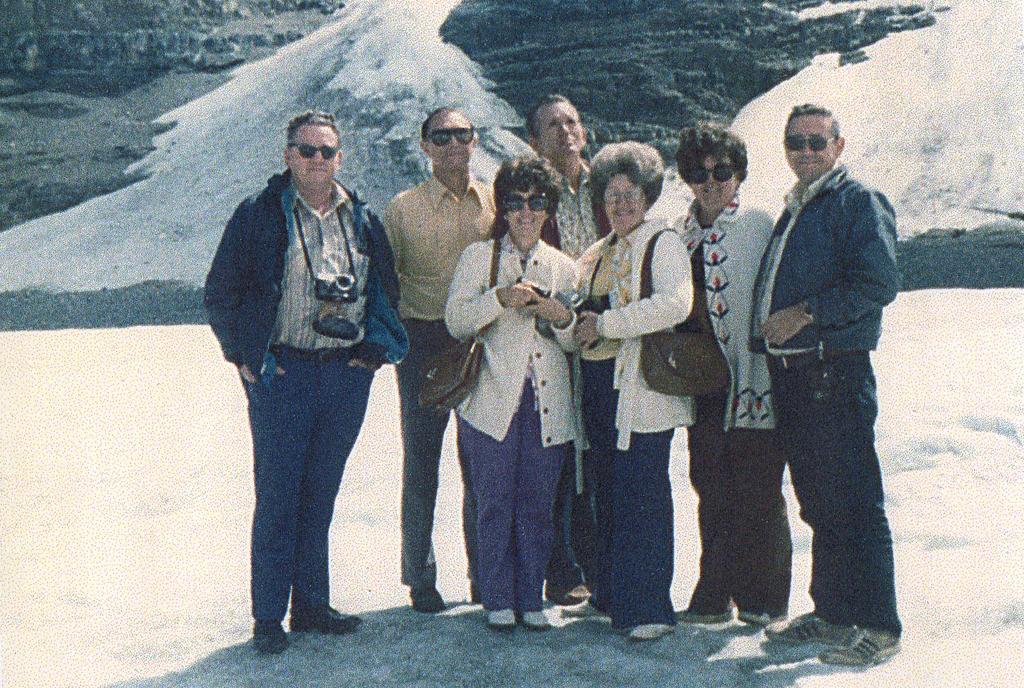Describe this image in one or two sentences. In the center of the image person standing on the snow. In the background we can see snow and mountain. 